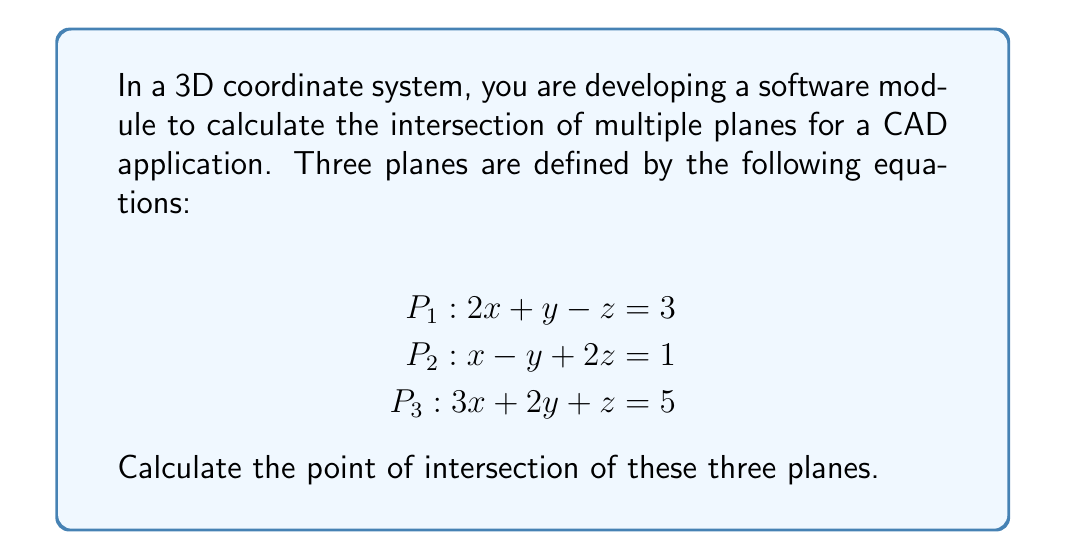Help me with this question. To find the intersection point of these three planes, we need to solve the system of linear equations they represent. We can use the following steps:

1. Set up the augmented matrix:

$$\begin{bmatrix}
2 & 1 & -1 & 3 \\
1 & -1 & 2 & 1 \\
3 & 2 & 1 & 5
\end{bmatrix}$$

2. Use Gaussian elimination to transform the matrix into row echelon form:

$$\begin{bmatrix}
2 & 1 & -1 & 3 \\
0 & -\frac{3}{2} & \frac{5}{2} & -\frac{1}{2} \\
0 & 0 & \frac{11}{3} & -\frac{1}{3}
\end{bmatrix}$$

3. Back-substitute to find the values of x, y, and z:

From the last row: $\frac{11}{3}z = -\frac{1}{3}$, so $z = -\frac{1}{11}$

From the second row: $-\frac{3}{2}y + \frac{5}{2}(-\frac{1}{11}) = -\frac{1}{2}$
Simplifying: $-\frac{3}{2}y - \frac{5}{22} = -\frac{1}{2}$
Solving for y: $y = \frac{6}{11}$

From the first row: $2x + 1(\frac{6}{11}) - 1(-\frac{1}{11}) = 3$
Simplifying: $2x + \frac{7}{11} = 3$
Solving for x: $x = \frac{26}{22} = \frac{13}{11}$

Therefore, the point of intersection is $(\frac{13}{11}, \frac{6}{11}, -\frac{1}{11})$.
Answer: The point of intersection of the three planes is $(\frac{13}{11}, \frac{6}{11}, -\frac{1}{11})$. 